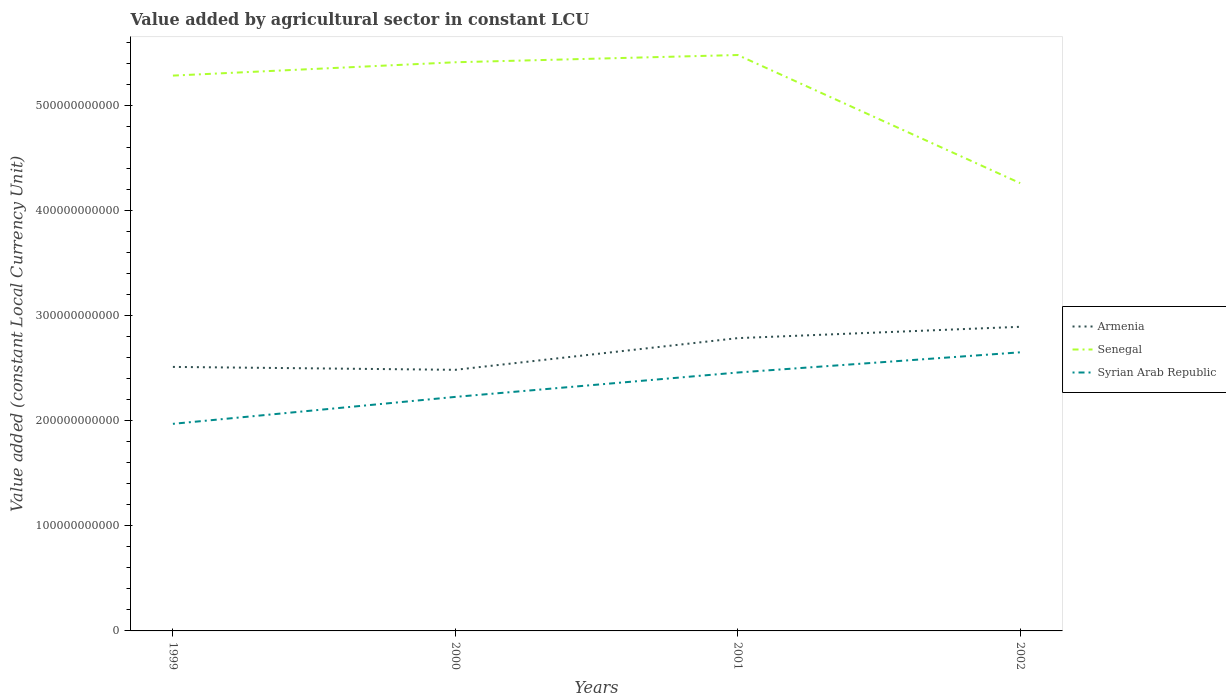Does the line corresponding to Armenia intersect with the line corresponding to Senegal?
Make the answer very short. No. Across all years, what is the maximum value added by agricultural sector in Armenia?
Keep it short and to the point. 2.49e+11. What is the total value added by agricultural sector in Armenia in the graph?
Your answer should be very brief. -1.08e+1. What is the difference between the highest and the second highest value added by agricultural sector in Armenia?
Give a very brief answer. 4.10e+1. Is the value added by agricultural sector in Armenia strictly greater than the value added by agricultural sector in Senegal over the years?
Make the answer very short. Yes. How many lines are there?
Ensure brevity in your answer.  3. How many years are there in the graph?
Your response must be concise. 4. What is the difference between two consecutive major ticks on the Y-axis?
Make the answer very short. 1.00e+11. Does the graph contain any zero values?
Keep it short and to the point. No. Where does the legend appear in the graph?
Keep it short and to the point. Center right. How many legend labels are there?
Give a very brief answer. 3. How are the legend labels stacked?
Make the answer very short. Vertical. What is the title of the graph?
Your response must be concise. Value added by agricultural sector in constant LCU. Does "Puerto Rico" appear as one of the legend labels in the graph?
Your answer should be very brief. No. What is the label or title of the Y-axis?
Keep it short and to the point. Value added (constant Local Currency Unit). What is the Value added (constant Local Currency Unit) in Armenia in 1999?
Give a very brief answer. 2.51e+11. What is the Value added (constant Local Currency Unit) in Senegal in 1999?
Your response must be concise. 5.29e+11. What is the Value added (constant Local Currency Unit) in Syrian Arab Republic in 1999?
Your answer should be compact. 1.97e+11. What is the Value added (constant Local Currency Unit) of Armenia in 2000?
Your answer should be very brief. 2.49e+11. What is the Value added (constant Local Currency Unit) in Senegal in 2000?
Offer a very short reply. 5.42e+11. What is the Value added (constant Local Currency Unit) of Syrian Arab Republic in 2000?
Keep it short and to the point. 2.23e+11. What is the Value added (constant Local Currency Unit) in Armenia in 2001?
Give a very brief answer. 2.79e+11. What is the Value added (constant Local Currency Unit) in Senegal in 2001?
Keep it short and to the point. 5.48e+11. What is the Value added (constant Local Currency Unit) of Syrian Arab Republic in 2001?
Keep it short and to the point. 2.46e+11. What is the Value added (constant Local Currency Unit) of Armenia in 2002?
Keep it short and to the point. 2.90e+11. What is the Value added (constant Local Currency Unit) in Senegal in 2002?
Your response must be concise. 4.26e+11. What is the Value added (constant Local Currency Unit) of Syrian Arab Republic in 2002?
Offer a terse response. 2.65e+11. Across all years, what is the maximum Value added (constant Local Currency Unit) in Armenia?
Offer a very short reply. 2.90e+11. Across all years, what is the maximum Value added (constant Local Currency Unit) of Senegal?
Your response must be concise. 5.48e+11. Across all years, what is the maximum Value added (constant Local Currency Unit) in Syrian Arab Republic?
Ensure brevity in your answer.  2.65e+11. Across all years, what is the minimum Value added (constant Local Currency Unit) of Armenia?
Provide a succinct answer. 2.49e+11. Across all years, what is the minimum Value added (constant Local Currency Unit) in Senegal?
Provide a short and direct response. 4.26e+11. Across all years, what is the minimum Value added (constant Local Currency Unit) in Syrian Arab Republic?
Keep it short and to the point. 1.97e+11. What is the total Value added (constant Local Currency Unit) in Armenia in the graph?
Offer a very short reply. 1.07e+12. What is the total Value added (constant Local Currency Unit) in Senegal in the graph?
Provide a succinct answer. 2.05e+12. What is the total Value added (constant Local Currency Unit) in Syrian Arab Republic in the graph?
Keep it short and to the point. 9.32e+11. What is the difference between the Value added (constant Local Currency Unit) of Armenia in 1999 and that in 2000?
Give a very brief answer. 2.77e+09. What is the difference between the Value added (constant Local Currency Unit) in Senegal in 1999 and that in 2000?
Ensure brevity in your answer.  -1.27e+1. What is the difference between the Value added (constant Local Currency Unit) of Syrian Arab Republic in 1999 and that in 2000?
Ensure brevity in your answer.  -2.57e+1. What is the difference between the Value added (constant Local Currency Unit) in Armenia in 1999 and that in 2001?
Keep it short and to the point. -2.74e+1. What is the difference between the Value added (constant Local Currency Unit) of Senegal in 1999 and that in 2001?
Ensure brevity in your answer.  -1.96e+1. What is the difference between the Value added (constant Local Currency Unit) of Syrian Arab Republic in 1999 and that in 2001?
Provide a short and direct response. -4.89e+1. What is the difference between the Value added (constant Local Currency Unit) in Armenia in 1999 and that in 2002?
Offer a very short reply. -3.82e+1. What is the difference between the Value added (constant Local Currency Unit) in Senegal in 1999 and that in 2002?
Your answer should be very brief. 1.02e+11. What is the difference between the Value added (constant Local Currency Unit) in Syrian Arab Republic in 1999 and that in 2002?
Offer a terse response. -6.81e+1. What is the difference between the Value added (constant Local Currency Unit) of Armenia in 2000 and that in 2001?
Provide a succinct answer. -3.02e+1. What is the difference between the Value added (constant Local Currency Unit) in Senegal in 2000 and that in 2001?
Your answer should be compact. -6.90e+09. What is the difference between the Value added (constant Local Currency Unit) in Syrian Arab Republic in 2000 and that in 2001?
Give a very brief answer. -2.32e+1. What is the difference between the Value added (constant Local Currency Unit) in Armenia in 2000 and that in 2002?
Offer a very short reply. -4.10e+1. What is the difference between the Value added (constant Local Currency Unit) in Senegal in 2000 and that in 2002?
Keep it short and to the point. 1.15e+11. What is the difference between the Value added (constant Local Currency Unit) of Syrian Arab Republic in 2000 and that in 2002?
Keep it short and to the point. -4.25e+1. What is the difference between the Value added (constant Local Currency Unit) in Armenia in 2001 and that in 2002?
Offer a very short reply. -1.08e+1. What is the difference between the Value added (constant Local Currency Unit) of Senegal in 2001 and that in 2002?
Your answer should be compact. 1.22e+11. What is the difference between the Value added (constant Local Currency Unit) of Syrian Arab Republic in 2001 and that in 2002?
Provide a short and direct response. -1.92e+1. What is the difference between the Value added (constant Local Currency Unit) of Armenia in 1999 and the Value added (constant Local Currency Unit) of Senegal in 2000?
Provide a succinct answer. -2.90e+11. What is the difference between the Value added (constant Local Currency Unit) in Armenia in 1999 and the Value added (constant Local Currency Unit) in Syrian Arab Republic in 2000?
Make the answer very short. 2.86e+1. What is the difference between the Value added (constant Local Currency Unit) of Senegal in 1999 and the Value added (constant Local Currency Unit) of Syrian Arab Republic in 2000?
Keep it short and to the point. 3.06e+11. What is the difference between the Value added (constant Local Currency Unit) in Armenia in 1999 and the Value added (constant Local Currency Unit) in Senegal in 2001?
Keep it short and to the point. -2.97e+11. What is the difference between the Value added (constant Local Currency Unit) of Armenia in 1999 and the Value added (constant Local Currency Unit) of Syrian Arab Republic in 2001?
Provide a short and direct response. 5.34e+09. What is the difference between the Value added (constant Local Currency Unit) in Senegal in 1999 and the Value added (constant Local Currency Unit) in Syrian Arab Republic in 2001?
Make the answer very short. 2.83e+11. What is the difference between the Value added (constant Local Currency Unit) of Armenia in 1999 and the Value added (constant Local Currency Unit) of Senegal in 2002?
Ensure brevity in your answer.  -1.75e+11. What is the difference between the Value added (constant Local Currency Unit) in Armenia in 1999 and the Value added (constant Local Currency Unit) in Syrian Arab Republic in 2002?
Provide a short and direct response. -1.39e+1. What is the difference between the Value added (constant Local Currency Unit) of Senegal in 1999 and the Value added (constant Local Currency Unit) of Syrian Arab Republic in 2002?
Offer a very short reply. 2.64e+11. What is the difference between the Value added (constant Local Currency Unit) of Armenia in 2000 and the Value added (constant Local Currency Unit) of Senegal in 2001?
Ensure brevity in your answer.  -3.00e+11. What is the difference between the Value added (constant Local Currency Unit) of Armenia in 2000 and the Value added (constant Local Currency Unit) of Syrian Arab Republic in 2001?
Provide a succinct answer. 2.57e+09. What is the difference between the Value added (constant Local Currency Unit) in Senegal in 2000 and the Value added (constant Local Currency Unit) in Syrian Arab Republic in 2001?
Provide a succinct answer. 2.95e+11. What is the difference between the Value added (constant Local Currency Unit) in Armenia in 2000 and the Value added (constant Local Currency Unit) in Senegal in 2002?
Keep it short and to the point. -1.78e+11. What is the difference between the Value added (constant Local Currency Unit) of Armenia in 2000 and the Value added (constant Local Currency Unit) of Syrian Arab Republic in 2002?
Offer a very short reply. -1.67e+1. What is the difference between the Value added (constant Local Currency Unit) of Senegal in 2000 and the Value added (constant Local Currency Unit) of Syrian Arab Republic in 2002?
Keep it short and to the point. 2.76e+11. What is the difference between the Value added (constant Local Currency Unit) of Armenia in 2001 and the Value added (constant Local Currency Unit) of Senegal in 2002?
Offer a terse response. -1.48e+11. What is the difference between the Value added (constant Local Currency Unit) in Armenia in 2001 and the Value added (constant Local Currency Unit) in Syrian Arab Republic in 2002?
Offer a terse response. 1.35e+1. What is the difference between the Value added (constant Local Currency Unit) of Senegal in 2001 and the Value added (constant Local Currency Unit) of Syrian Arab Republic in 2002?
Provide a short and direct response. 2.83e+11. What is the average Value added (constant Local Currency Unit) in Armenia per year?
Your answer should be compact. 2.67e+11. What is the average Value added (constant Local Currency Unit) in Senegal per year?
Your answer should be very brief. 5.11e+11. What is the average Value added (constant Local Currency Unit) in Syrian Arab Republic per year?
Provide a succinct answer. 2.33e+11. In the year 1999, what is the difference between the Value added (constant Local Currency Unit) in Armenia and Value added (constant Local Currency Unit) in Senegal?
Ensure brevity in your answer.  -2.77e+11. In the year 1999, what is the difference between the Value added (constant Local Currency Unit) of Armenia and Value added (constant Local Currency Unit) of Syrian Arab Republic?
Keep it short and to the point. 5.42e+1. In the year 1999, what is the difference between the Value added (constant Local Currency Unit) of Senegal and Value added (constant Local Currency Unit) of Syrian Arab Republic?
Your response must be concise. 3.32e+11. In the year 2000, what is the difference between the Value added (constant Local Currency Unit) of Armenia and Value added (constant Local Currency Unit) of Senegal?
Your answer should be very brief. -2.93e+11. In the year 2000, what is the difference between the Value added (constant Local Currency Unit) in Armenia and Value added (constant Local Currency Unit) in Syrian Arab Republic?
Make the answer very short. 2.58e+1. In the year 2000, what is the difference between the Value added (constant Local Currency Unit) of Senegal and Value added (constant Local Currency Unit) of Syrian Arab Republic?
Your response must be concise. 3.19e+11. In the year 2001, what is the difference between the Value added (constant Local Currency Unit) in Armenia and Value added (constant Local Currency Unit) in Senegal?
Offer a very short reply. -2.70e+11. In the year 2001, what is the difference between the Value added (constant Local Currency Unit) in Armenia and Value added (constant Local Currency Unit) in Syrian Arab Republic?
Provide a succinct answer. 3.28e+1. In the year 2001, what is the difference between the Value added (constant Local Currency Unit) of Senegal and Value added (constant Local Currency Unit) of Syrian Arab Republic?
Offer a very short reply. 3.02e+11. In the year 2002, what is the difference between the Value added (constant Local Currency Unit) of Armenia and Value added (constant Local Currency Unit) of Senegal?
Offer a very short reply. -1.37e+11. In the year 2002, what is the difference between the Value added (constant Local Currency Unit) of Armenia and Value added (constant Local Currency Unit) of Syrian Arab Republic?
Offer a terse response. 2.43e+1. In the year 2002, what is the difference between the Value added (constant Local Currency Unit) of Senegal and Value added (constant Local Currency Unit) of Syrian Arab Republic?
Provide a short and direct response. 1.61e+11. What is the ratio of the Value added (constant Local Currency Unit) of Armenia in 1999 to that in 2000?
Your answer should be very brief. 1.01. What is the ratio of the Value added (constant Local Currency Unit) of Senegal in 1999 to that in 2000?
Make the answer very short. 0.98. What is the ratio of the Value added (constant Local Currency Unit) of Syrian Arab Republic in 1999 to that in 2000?
Ensure brevity in your answer.  0.88. What is the ratio of the Value added (constant Local Currency Unit) of Armenia in 1999 to that in 2001?
Ensure brevity in your answer.  0.9. What is the ratio of the Value added (constant Local Currency Unit) of Senegal in 1999 to that in 2001?
Give a very brief answer. 0.96. What is the ratio of the Value added (constant Local Currency Unit) of Syrian Arab Republic in 1999 to that in 2001?
Offer a terse response. 0.8. What is the ratio of the Value added (constant Local Currency Unit) of Armenia in 1999 to that in 2002?
Provide a succinct answer. 0.87. What is the ratio of the Value added (constant Local Currency Unit) in Senegal in 1999 to that in 2002?
Make the answer very short. 1.24. What is the ratio of the Value added (constant Local Currency Unit) in Syrian Arab Republic in 1999 to that in 2002?
Offer a terse response. 0.74. What is the ratio of the Value added (constant Local Currency Unit) in Armenia in 2000 to that in 2001?
Make the answer very short. 0.89. What is the ratio of the Value added (constant Local Currency Unit) of Senegal in 2000 to that in 2001?
Provide a short and direct response. 0.99. What is the ratio of the Value added (constant Local Currency Unit) in Syrian Arab Republic in 2000 to that in 2001?
Provide a succinct answer. 0.91. What is the ratio of the Value added (constant Local Currency Unit) of Armenia in 2000 to that in 2002?
Your answer should be very brief. 0.86. What is the ratio of the Value added (constant Local Currency Unit) of Senegal in 2000 to that in 2002?
Keep it short and to the point. 1.27. What is the ratio of the Value added (constant Local Currency Unit) of Syrian Arab Republic in 2000 to that in 2002?
Your response must be concise. 0.84. What is the ratio of the Value added (constant Local Currency Unit) in Armenia in 2001 to that in 2002?
Your response must be concise. 0.96. What is the ratio of the Value added (constant Local Currency Unit) in Senegal in 2001 to that in 2002?
Provide a short and direct response. 1.29. What is the ratio of the Value added (constant Local Currency Unit) in Syrian Arab Republic in 2001 to that in 2002?
Your answer should be compact. 0.93. What is the difference between the highest and the second highest Value added (constant Local Currency Unit) in Armenia?
Make the answer very short. 1.08e+1. What is the difference between the highest and the second highest Value added (constant Local Currency Unit) of Senegal?
Keep it short and to the point. 6.90e+09. What is the difference between the highest and the second highest Value added (constant Local Currency Unit) of Syrian Arab Republic?
Provide a short and direct response. 1.92e+1. What is the difference between the highest and the lowest Value added (constant Local Currency Unit) of Armenia?
Your response must be concise. 4.10e+1. What is the difference between the highest and the lowest Value added (constant Local Currency Unit) of Senegal?
Offer a very short reply. 1.22e+11. What is the difference between the highest and the lowest Value added (constant Local Currency Unit) in Syrian Arab Republic?
Keep it short and to the point. 6.81e+1. 